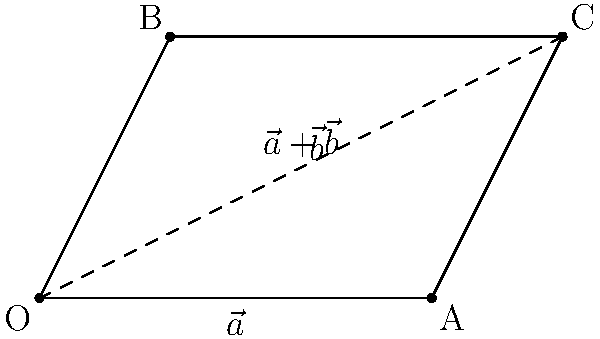Imagine you're explaining vector addition to your students using the parallelogram method. In this diagram, vectors $\vec{a}$ and $\vec{b}$ form two sides of a parallelogram. If $\vec{a} = 3\hat{i}$ and $\vec{b} = \hat{i} + 2\hat{j}$, what is the magnitude of the resultant vector $\vec{a} + \vec{b}$? Let's approach this step-by-step:

1) First, recall that the diagonal of the parallelogram represents the sum of the two vectors $\vec{a} + \vec{b}$.

2) We can find the components of the resultant vector:
   $\vec{a} + \vec{b} = (3\hat{i}) + (\hat{i} + 2\hat{j}) = 4\hat{i} + 2\hat{j}$

3) Now, we can use the Pythagorean theorem to find the magnitude of this resultant vector. If we call the magnitude $|\vec{a} + \vec{b}|$, then:

   $|\vec{a} + \vec{b}| = \sqrt{(4)^2 + (2)^2}$

4) Simplify:
   $|\vec{a} + \vec{b}| = \sqrt{16 + 4} = \sqrt{20}$

5) Simplify the square root:
   $|\vec{a} + \vec{b}| = 2\sqrt{5}$

Thus, the magnitude of the resultant vector is $2\sqrt{5}$.
Answer: $2\sqrt{5}$ 